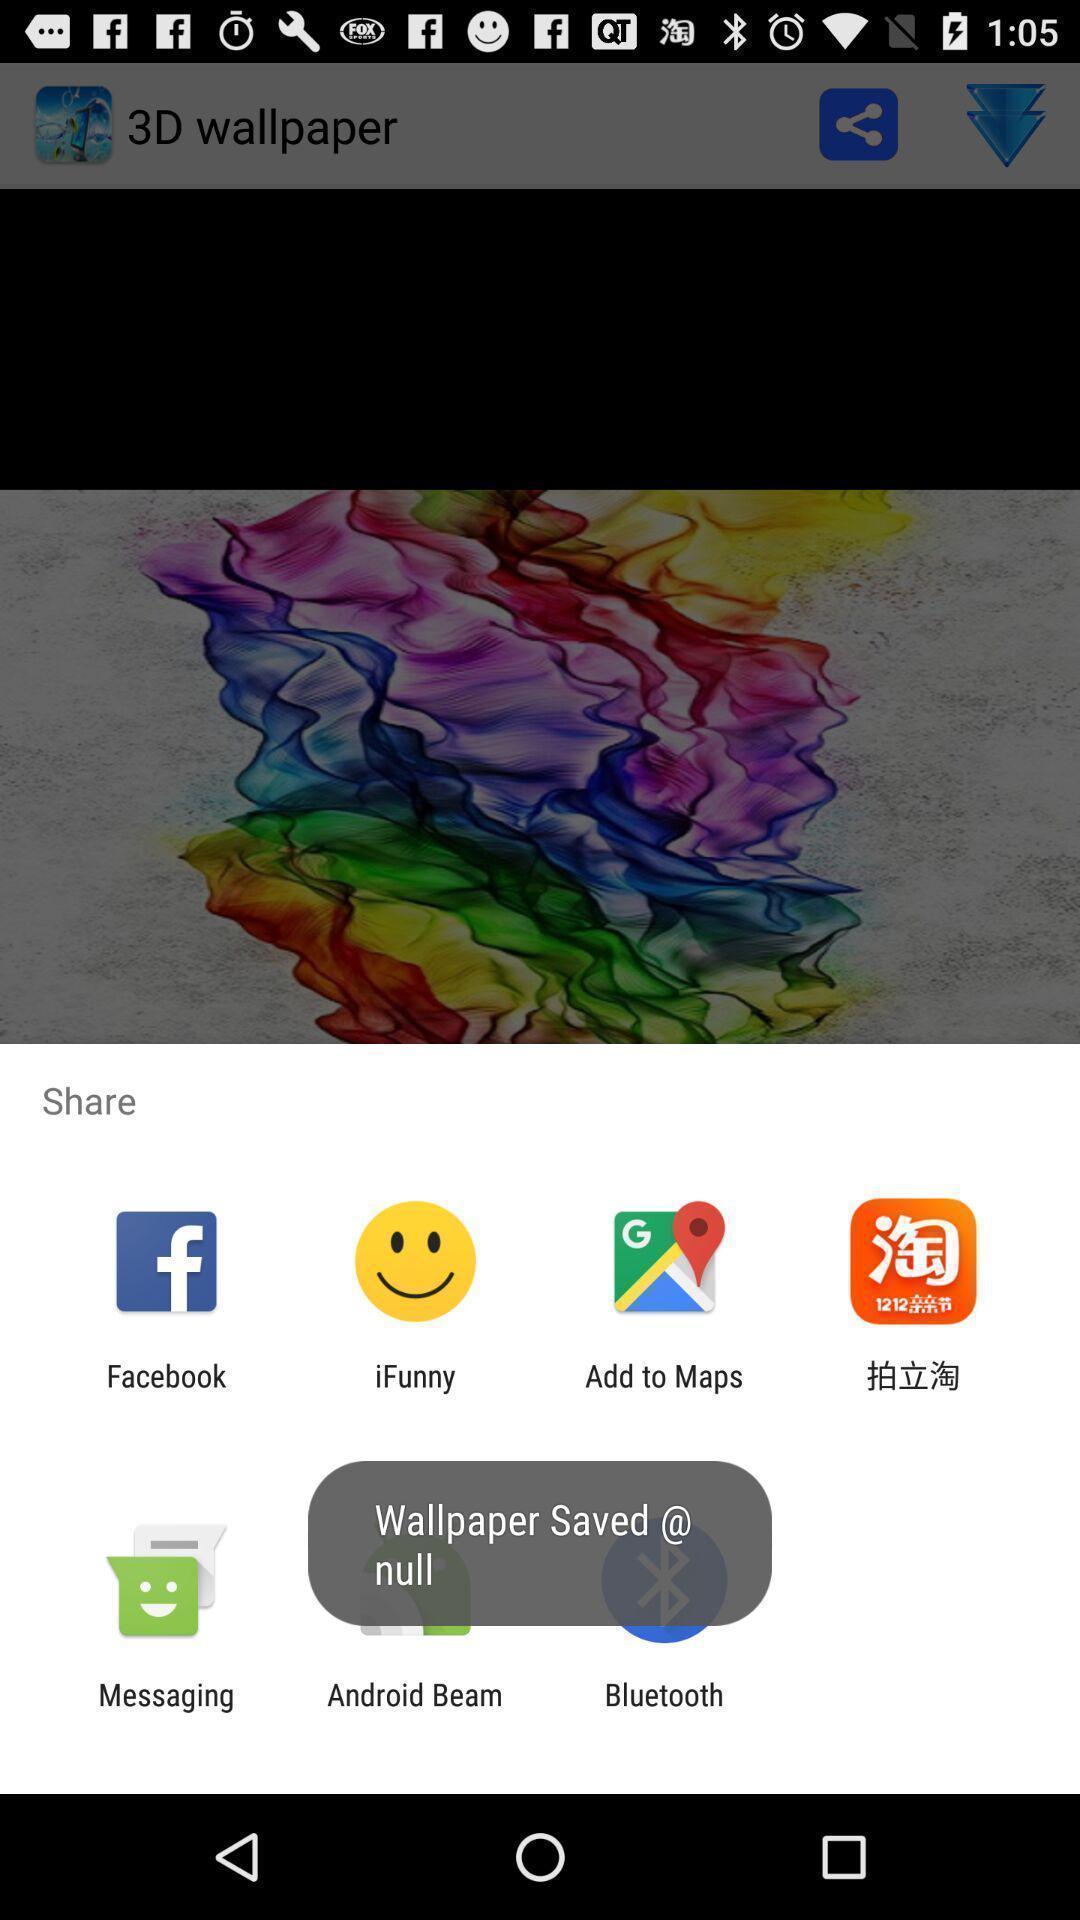Explain what's happening in this screen capture. Pop-up to share using different apps. 